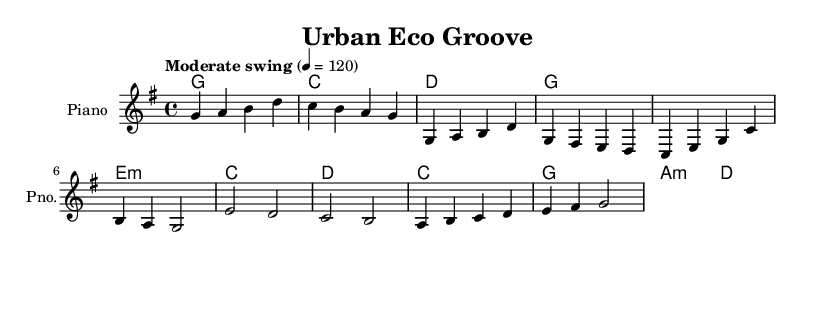What is the key signature of this music? The key signature is G major, which has one sharp (F#). This can be identified by looking at the beginning of the staff where the key signature is placed.
Answer: G major What is the time signature of this music? The time signature is 4/4, indicated at the beginning of the score after the clef and key signature. This means there are four beats in each measure.
Answer: 4/4 What is the tempo marking of this music? The tempo marking is "Moderate swing" at a metronome marking of 120. This can be found at the beginning of the score above the staff, indicating how the piece should be played.
Answer: Moderate swing How many measures are in the A Section of the piece? The A Section comprises 4 measures, identifiable by the presence of two phrases, each containing 2 measures. This can be counted from the music notes in that section.
Answer: 4 What is the first chord played in the B Section? The first chord in the B Section is C major. This can be determined by looking at the chord names above the corresponding measures in the B Section, which shows C as the chord played.
Answer: C Which instrument is indicated for this score? The instrument indicated is Piano, as mentioned in the score where it specifies the instrument's name at the beginning of the staff.
Answer: Piano What musical form does this piece reflect based on the A-B structure? This piece reflects a Verse-Chorus form since it has an A-B structure, with each section embodying distinct melodic content typical in jazz compositions.
Answer: Verse-Chorus 